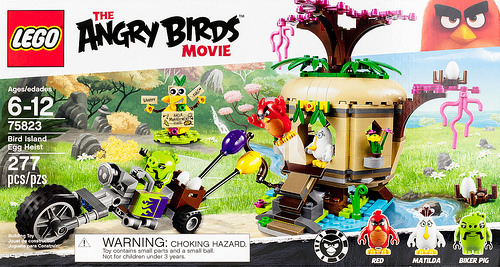<image>
Is there a motorcycle to the right of the tire? No. The motorcycle is not to the right of the tire. The horizontal positioning shows a different relationship. 